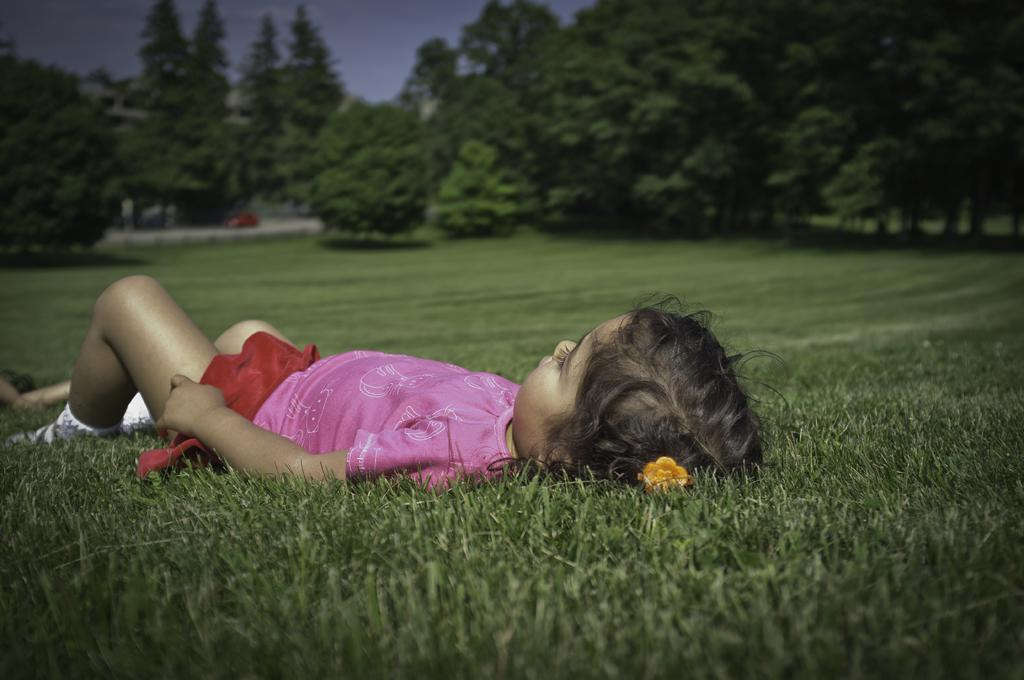What is the girl in the foreground of the image doing? The girl is lying on the grass in the foreground of the image. What can be seen in the background of the image? There are trees, a vehicle on the road, and the sky visible in the background of the image. What type of design can be seen on the pig in the image? There is no pig present in the image, so it is not possible to answer that question. 